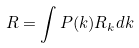<formula> <loc_0><loc_0><loc_500><loc_500>R = \int P ( k ) R _ { k } d k</formula> 